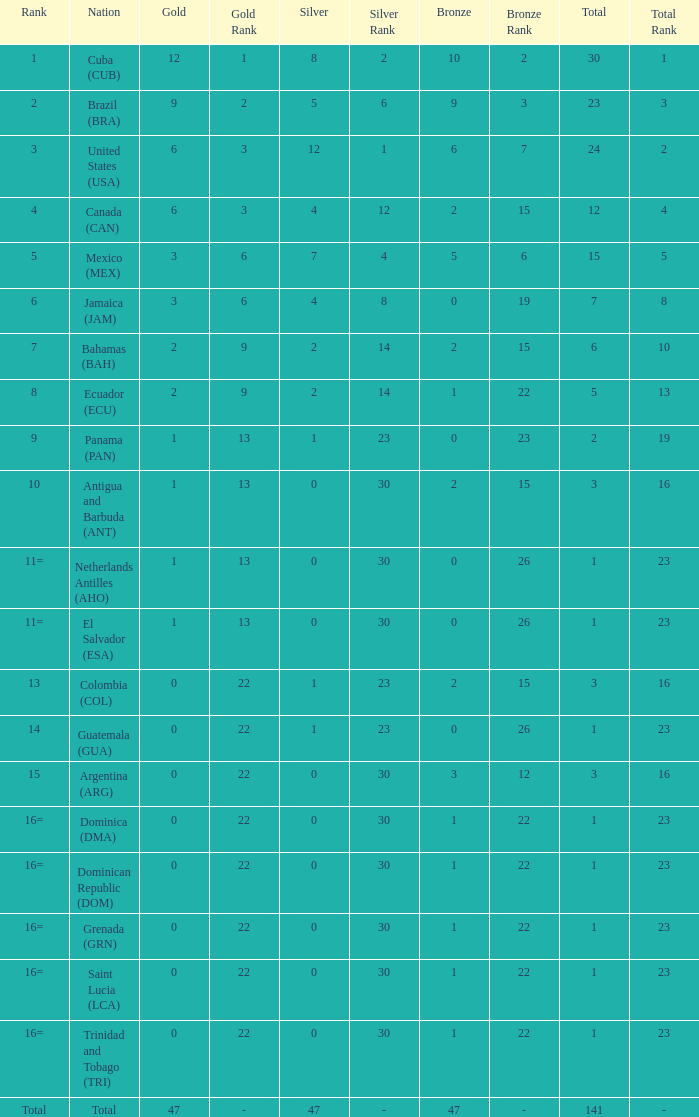How many bronzes have a Nation of jamaica (jam), and a Total smaller than 7? 0.0. 